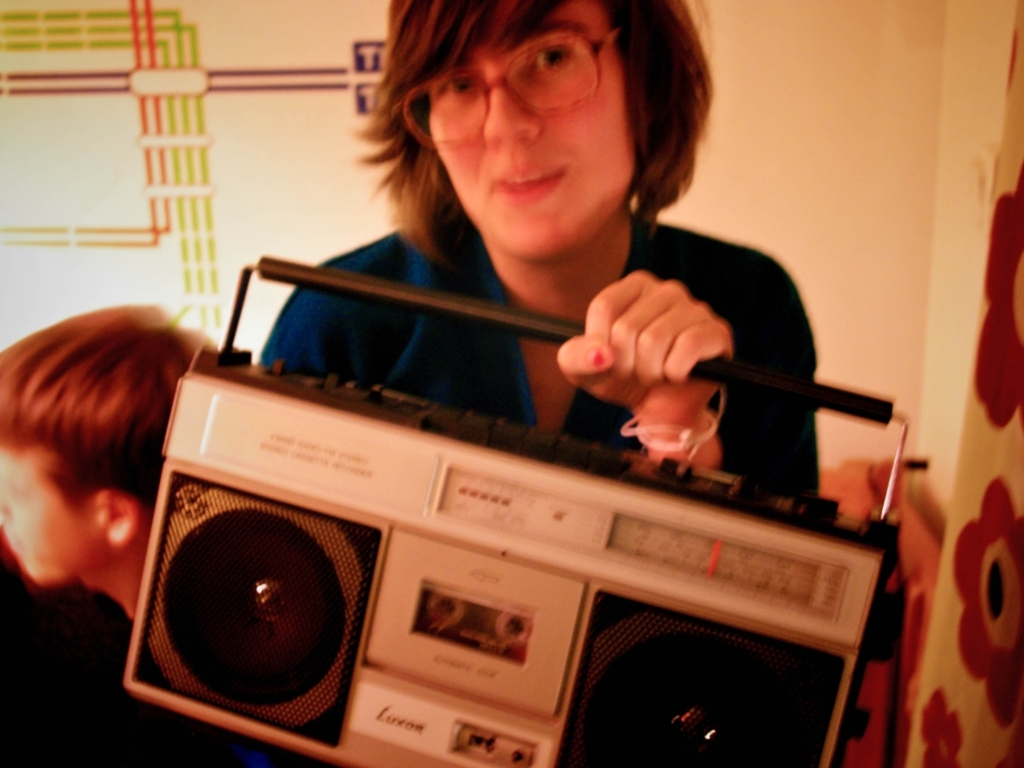Can you describe what the person is doing in the image? The person is holding a portable cassette player with one hand and adjusting the antenna with the other, possibly trying to tune into a radio station or improve reception. 